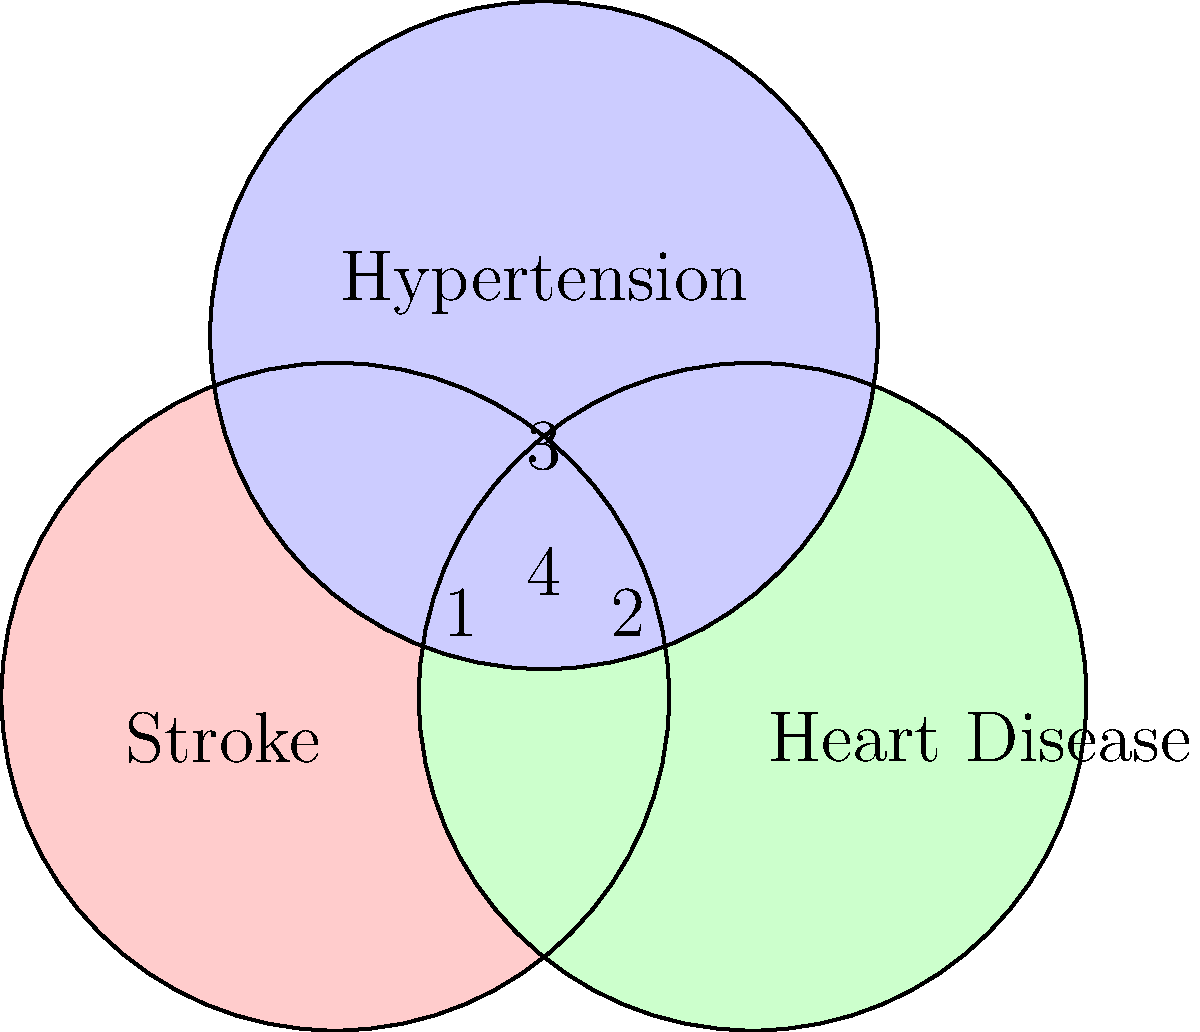As a politician advocating for better healthcare policies for stroke survivors, you're presented with a Venn diagram showing the overlapping risk factors for stroke, heart disease, and hypertension. The diagram has four distinct regions labeled 1, 2, 3, and 4. Which region represents risk factors that are common to all three conditions? To answer this question, we need to analyze the Venn diagram:

1. The diagram consists of three overlapping circles representing Stroke, Heart Disease, and Hypertension.

2. The overlapping regions indicate shared risk factors:
   - Region 1: Unique to Stroke
   - Region 2: Unique to Heart Disease
   - Region 3: Unique to Hypertension
   - Region 4: The central area where all three circles overlap

3. The question asks for risk factors common to all three conditions.

4. The region that represents factors common to all three conditions is the area where all three circles intersect.

5. This central intersection point is labeled as region 4 in the diagram.

Therefore, region 4 represents the risk factors that are common to stroke, heart disease, and hypertension.
Answer: Region 4 